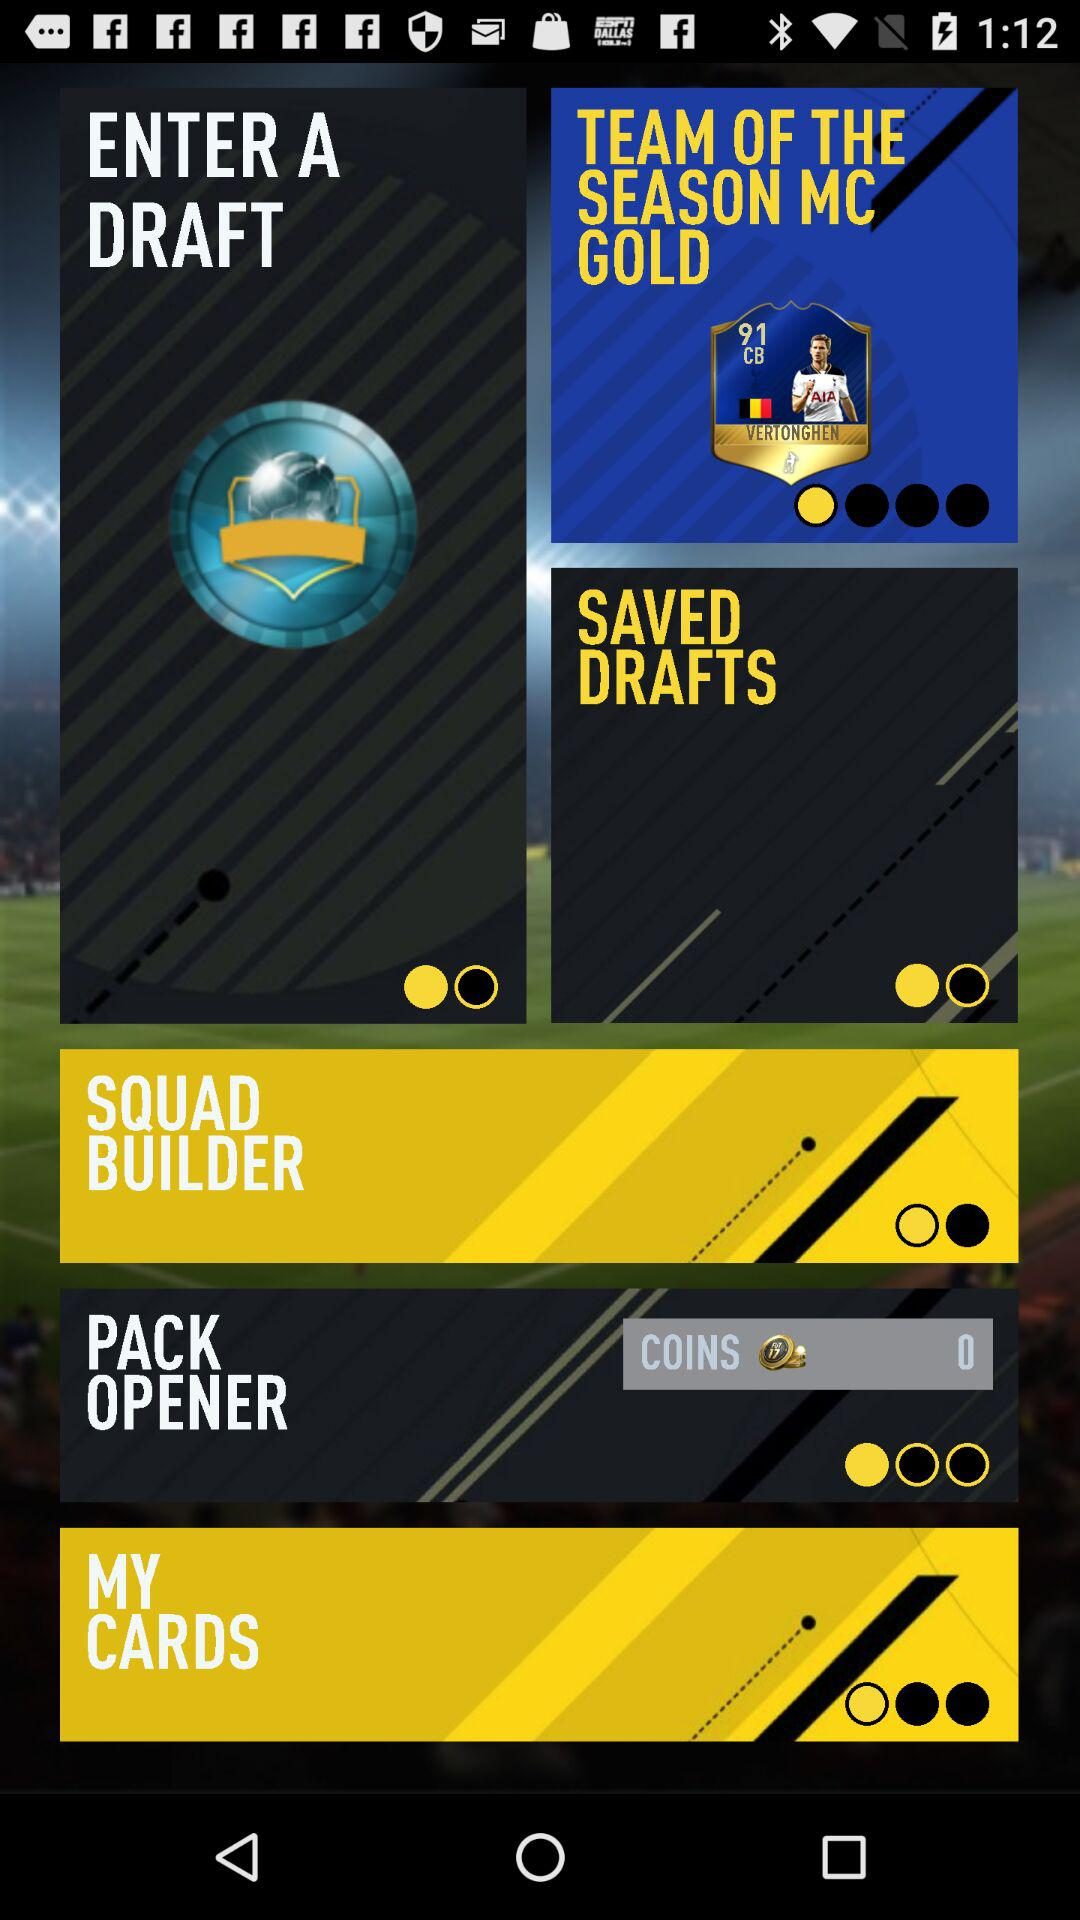How many cards do you have?
When the provided information is insufficient, respond with <no answer>. <no answer> 